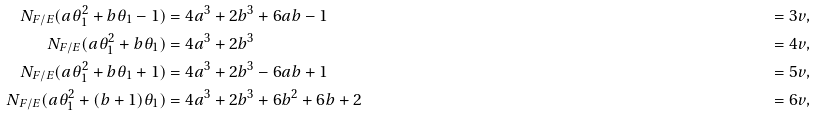<formula> <loc_0><loc_0><loc_500><loc_500>N _ { F / E } ( a \theta _ { 1 } ^ { 2 } + b \theta _ { 1 } - 1 ) & = 4 a ^ { 3 } + 2 b ^ { 3 } + 6 a b - 1 & = 3 v , \\ N _ { F / E } ( a \theta _ { 1 } ^ { 2 } + b \theta _ { 1 } ) & = 4 a ^ { 3 } + 2 b ^ { 3 } & = 4 v , \\ N _ { F / E } ( a \theta _ { 1 } ^ { 2 } + b \theta _ { 1 } + 1 ) & = 4 a ^ { 3 } + 2 b ^ { 3 } - 6 a b + 1 & = 5 v , \\ N _ { F / E } ( a \theta _ { 1 } ^ { 2 } + ( b + 1 ) \theta _ { 1 } ) & = 4 a ^ { 3 } + 2 b ^ { 3 } + 6 b ^ { 2 } + 6 b + 2 & = 6 v , \\</formula> 